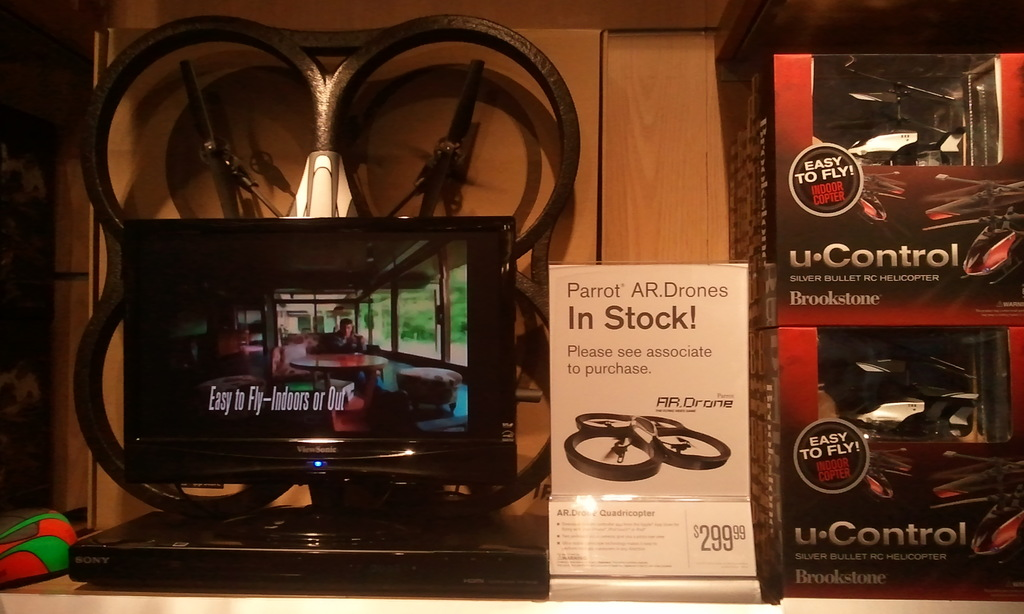Provide a one-sentence caption for the provided image.
Reference OCR token: TOFLY!, u.Control, Parrot, R.Drones, SLVEBULEEC, LICOPTER, Brookstone, In, Stock!, Please, associate, purchase., EasytoFly-Indoos, Indoors, Our, AR, TOTFLY!, $29999, u.Control, HELCOPTER, Brookstone A shelf has a portable DVD player on it and drones with a sign that says Parrot AR Drones In Stock. 